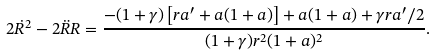<formula> <loc_0><loc_0><loc_500><loc_500>2 \dot { R } ^ { 2 } - 2 \ddot { R } R = \frac { - ( 1 + \gamma ) \left [ r a ^ { \prime } + a ( 1 + a ) \right ] + a ( 1 + a ) + \gamma r a ^ { \prime } / 2 } { ( 1 + \gamma ) r ^ { 2 } ( 1 + a ) ^ { 2 } } .</formula> 